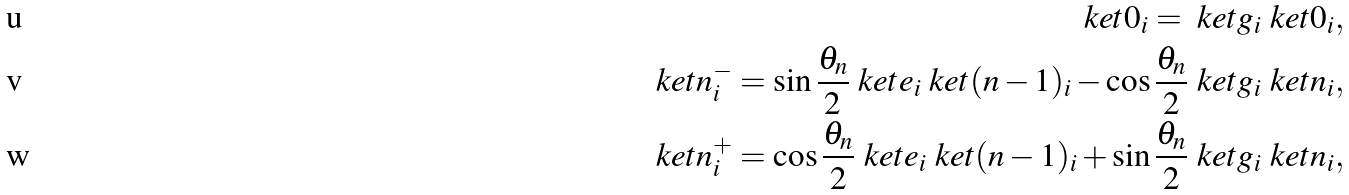Convert formula to latex. <formula><loc_0><loc_0><loc_500><loc_500>\ k e t { 0 _ { i } } = \ k e t { g _ { i } } \ k e t { 0 _ { i } } , \\ \ k e t { n _ { i } ^ { - } } = \sin \frac { \theta _ { n } } { 2 } \ k e t { e _ { i } } \ k e t { ( n - 1 ) _ { i } } - \cos \frac { \theta _ { n } } { 2 } \ k e t { g _ { i } } \ k e t { n _ { i } } , \\ \ k e t { n _ { i } ^ { + } } = \cos \frac { \theta _ { n } } { 2 } \ k e t { e _ { i } } \ k e t { ( n - 1 ) _ { i } } + \sin \frac { \theta _ { n } } { 2 } \ k e t { g _ { i } } \ k e t { n _ { i } } ,</formula> 